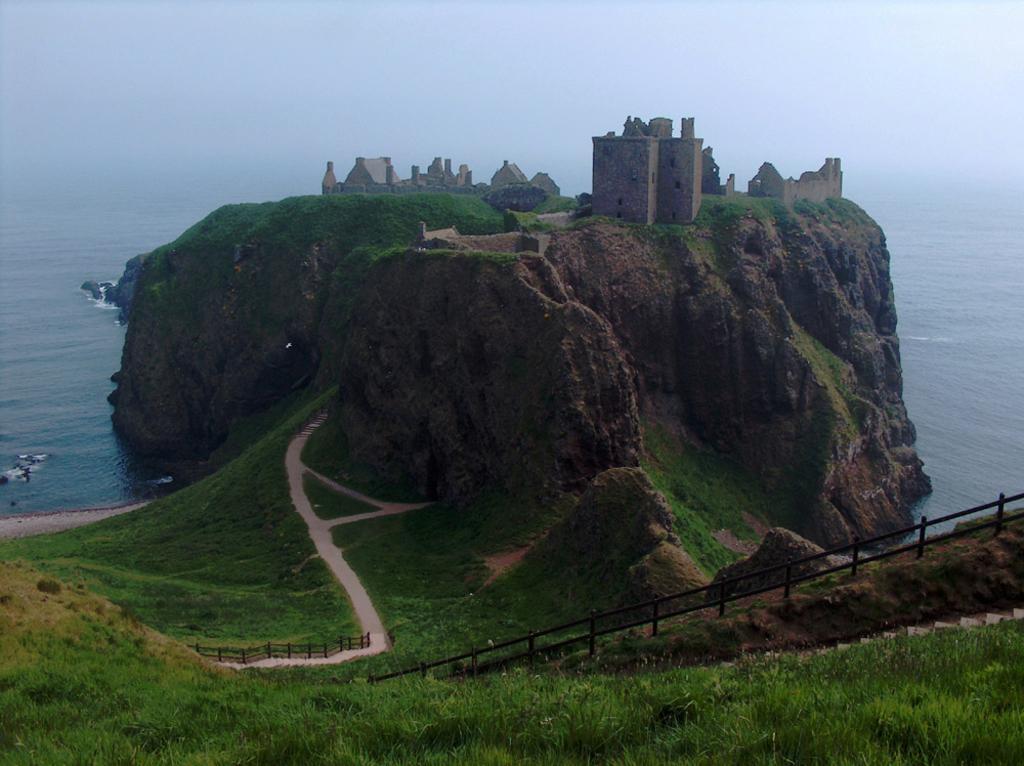How would you summarize this image in a sentence or two? In this picture we can see a beautiful view of the mountain. On the top we can see a brown castle house on the mountain. In the front bottom side we can see grass on the ground and black pipe railing. In the background there is sea water.  